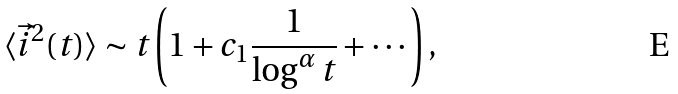<formula> <loc_0><loc_0><loc_500><loc_500>\langle \vec { i } ^ { 2 } ( t ) \rangle \sim t \left ( 1 + c _ { 1 } \frac { 1 } { \log ^ { \alpha } t } + \cdots \right ) ,</formula> 